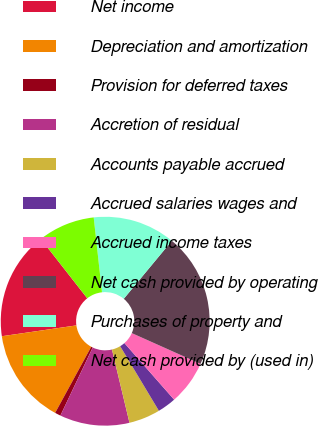Convert chart. <chart><loc_0><loc_0><loc_500><loc_500><pie_chart><fcel>Net income<fcel>Depreciation and amortization<fcel>Provision for deferred taxes<fcel>Accretion of residual<fcel>Accounts payable accrued<fcel>Accrued salaries wages and<fcel>Accrued income taxes<fcel>Net cash provided by operating<fcel>Purchases of property and<fcel>Net cash provided by (used in)<nl><fcel>16.73%<fcel>14.75%<fcel>0.9%<fcel>10.79%<fcel>4.86%<fcel>2.88%<fcel>6.83%<fcel>20.68%<fcel>12.77%<fcel>8.81%<nl></chart> 